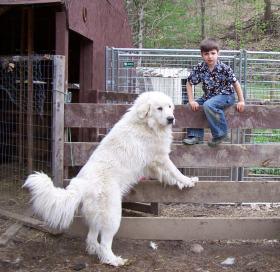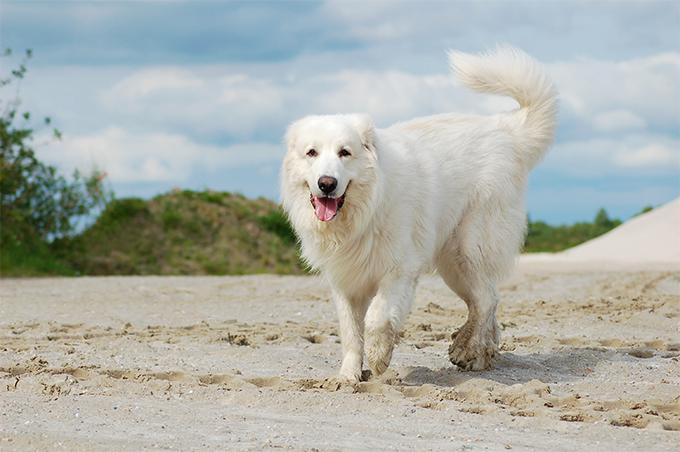The first image is the image on the left, the second image is the image on the right. For the images displayed, is the sentence "There is a large dog with a child in one image, and a similar dog with it's mouth open in the other." factually correct? Answer yes or no. Yes. The first image is the image on the left, the second image is the image on the right. For the images shown, is this caption "One dog is laying in the dirt." true? Answer yes or no. No. 